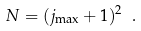<formula> <loc_0><loc_0><loc_500><loc_500>N = ( j _ { \max } + 1 ) ^ { 2 } \ .</formula> 